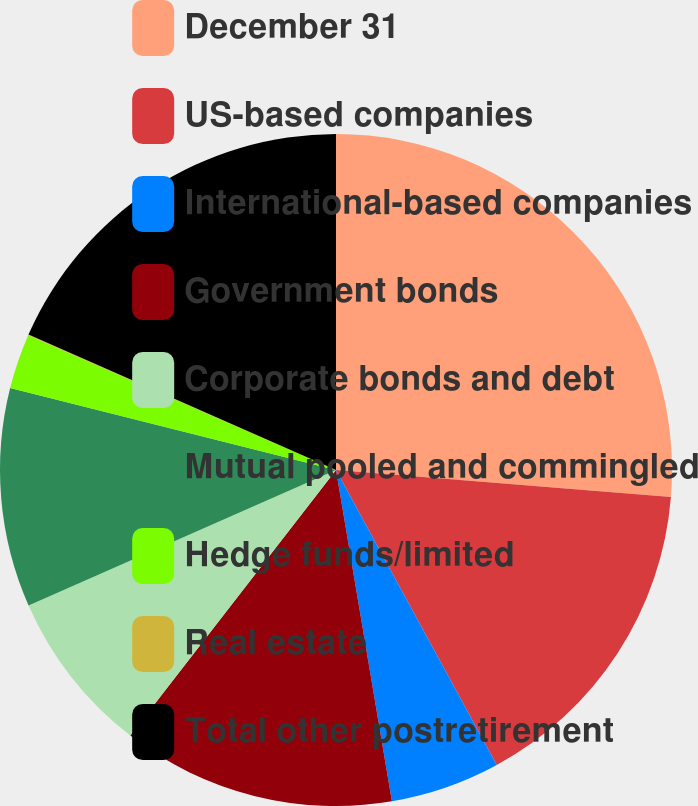Convert chart to OTSL. <chart><loc_0><loc_0><loc_500><loc_500><pie_chart><fcel>December 31<fcel>US-based companies<fcel>International-based companies<fcel>Government bonds<fcel>Corporate bonds and debt<fcel>Mutual pooled and commingled<fcel>Hedge funds/limited<fcel>Real estate<fcel>Total other postretirement<nl><fcel>26.28%<fcel>15.78%<fcel>5.28%<fcel>13.15%<fcel>7.9%<fcel>10.53%<fcel>2.65%<fcel>0.03%<fcel>18.4%<nl></chart> 